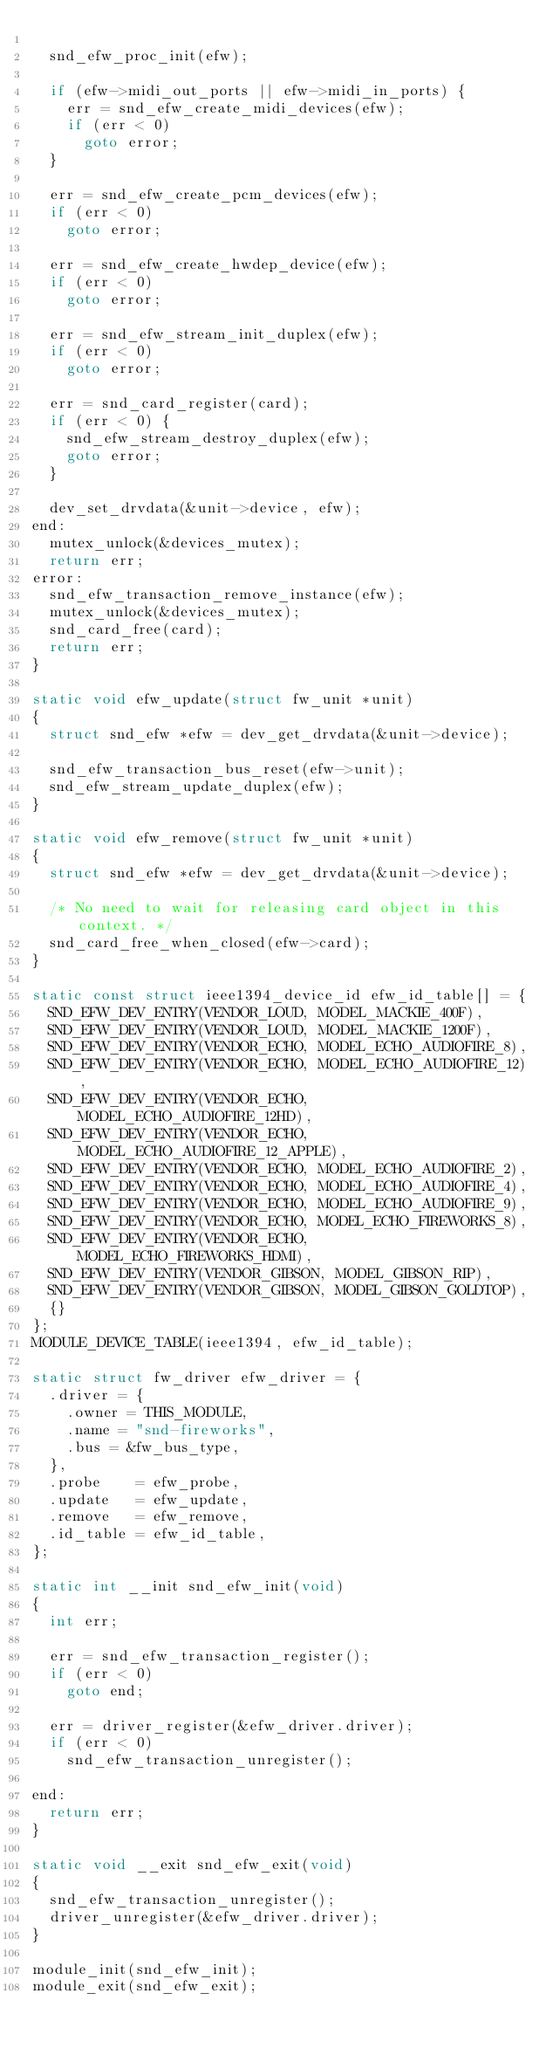<code> <loc_0><loc_0><loc_500><loc_500><_C_>
	snd_efw_proc_init(efw);

	if (efw->midi_out_ports || efw->midi_in_ports) {
		err = snd_efw_create_midi_devices(efw);
		if (err < 0)
			goto error;
	}

	err = snd_efw_create_pcm_devices(efw);
	if (err < 0)
		goto error;

	err = snd_efw_create_hwdep_device(efw);
	if (err < 0)
		goto error;

	err = snd_efw_stream_init_duplex(efw);
	if (err < 0)
		goto error;

	err = snd_card_register(card);
	if (err < 0) {
		snd_efw_stream_destroy_duplex(efw);
		goto error;
	}

	dev_set_drvdata(&unit->device, efw);
end:
	mutex_unlock(&devices_mutex);
	return err;
error:
	snd_efw_transaction_remove_instance(efw);
	mutex_unlock(&devices_mutex);
	snd_card_free(card);
	return err;
}

static void efw_update(struct fw_unit *unit)
{
	struct snd_efw *efw = dev_get_drvdata(&unit->device);

	snd_efw_transaction_bus_reset(efw->unit);
	snd_efw_stream_update_duplex(efw);
}

static void efw_remove(struct fw_unit *unit)
{
	struct snd_efw *efw = dev_get_drvdata(&unit->device);

	/* No need to wait for releasing card object in this context. */
	snd_card_free_when_closed(efw->card);
}

static const struct ieee1394_device_id efw_id_table[] = {
	SND_EFW_DEV_ENTRY(VENDOR_LOUD, MODEL_MACKIE_400F),
	SND_EFW_DEV_ENTRY(VENDOR_LOUD, MODEL_MACKIE_1200F),
	SND_EFW_DEV_ENTRY(VENDOR_ECHO, MODEL_ECHO_AUDIOFIRE_8),
	SND_EFW_DEV_ENTRY(VENDOR_ECHO, MODEL_ECHO_AUDIOFIRE_12),
	SND_EFW_DEV_ENTRY(VENDOR_ECHO, MODEL_ECHO_AUDIOFIRE_12HD),
	SND_EFW_DEV_ENTRY(VENDOR_ECHO, MODEL_ECHO_AUDIOFIRE_12_APPLE),
	SND_EFW_DEV_ENTRY(VENDOR_ECHO, MODEL_ECHO_AUDIOFIRE_2),
	SND_EFW_DEV_ENTRY(VENDOR_ECHO, MODEL_ECHO_AUDIOFIRE_4),
	SND_EFW_DEV_ENTRY(VENDOR_ECHO, MODEL_ECHO_AUDIOFIRE_9),
	SND_EFW_DEV_ENTRY(VENDOR_ECHO, MODEL_ECHO_FIREWORKS_8),
	SND_EFW_DEV_ENTRY(VENDOR_ECHO, MODEL_ECHO_FIREWORKS_HDMI),
	SND_EFW_DEV_ENTRY(VENDOR_GIBSON, MODEL_GIBSON_RIP),
	SND_EFW_DEV_ENTRY(VENDOR_GIBSON, MODEL_GIBSON_GOLDTOP),
	{}
};
MODULE_DEVICE_TABLE(ieee1394, efw_id_table);

static struct fw_driver efw_driver = {
	.driver = {
		.owner = THIS_MODULE,
		.name = "snd-fireworks",
		.bus = &fw_bus_type,
	},
	.probe    = efw_probe,
	.update   = efw_update,
	.remove   = efw_remove,
	.id_table = efw_id_table,
};

static int __init snd_efw_init(void)
{
	int err;

	err = snd_efw_transaction_register();
	if (err < 0)
		goto end;

	err = driver_register(&efw_driver.driver);
	if (err < 0)
		snd_efw_transaction_unregister();

end:
	return err;
}

static void __exit snd_efw_exit(void)
{
	snd_efw_transaction_unregister();
	driver_unregister(&efw_driver.driver);
}

module_init(snd_efw_init);
module_exit(snd_efw_exit);
</code> 